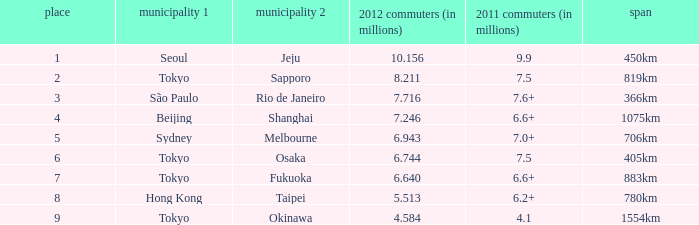How many passengers (in millions) flew from Seoul in 2012? 10.156. 